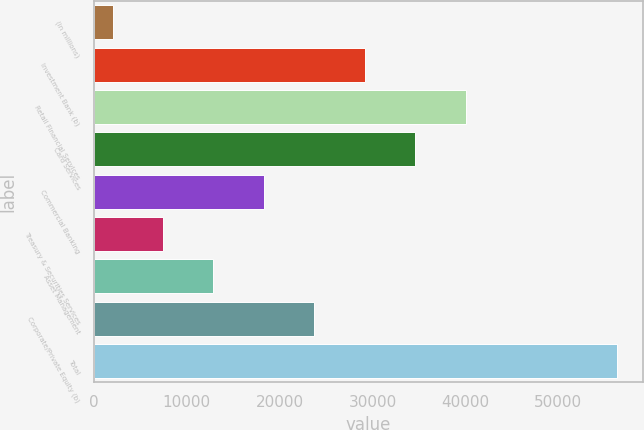Convert chart to OTSL. <chart><loc_0><loc_0><loc_500><loc_500><bar_chart><fcel>(in millions)<fcel>Investment Bank (b)<fcel>Retail Financial Services<fcel>Card Services<fcel>Commercial Banking<fcel>Treasury & Securities Services<fcel>Asset Management<fcel>Corporate/Private Equity (b)<fcel>Total<nl><fcel>2009<fcel>29152<fcel>40009.2<fcel>34580.6<fcel>18294.8<fcel>7437.6<fcel>12866.2<fcel>23723.4<fcel>56295<nl></chart> 